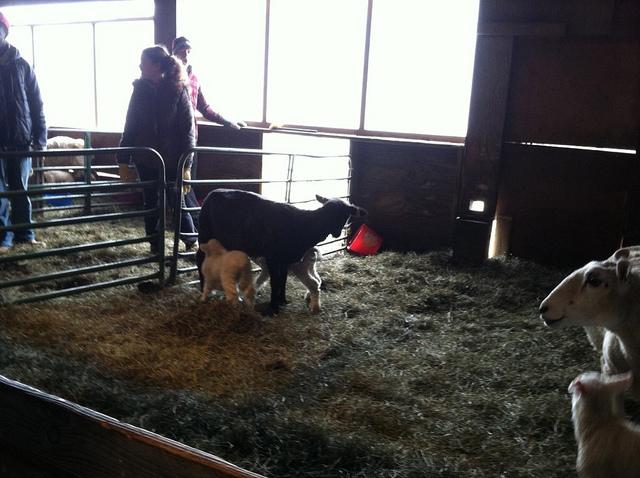What animals are these?
Answer briefly. Goats. Are the animals in the photo free to roam?
Short answer required. No. Are there any baby animals?
Give a very brief answer. Yes. 